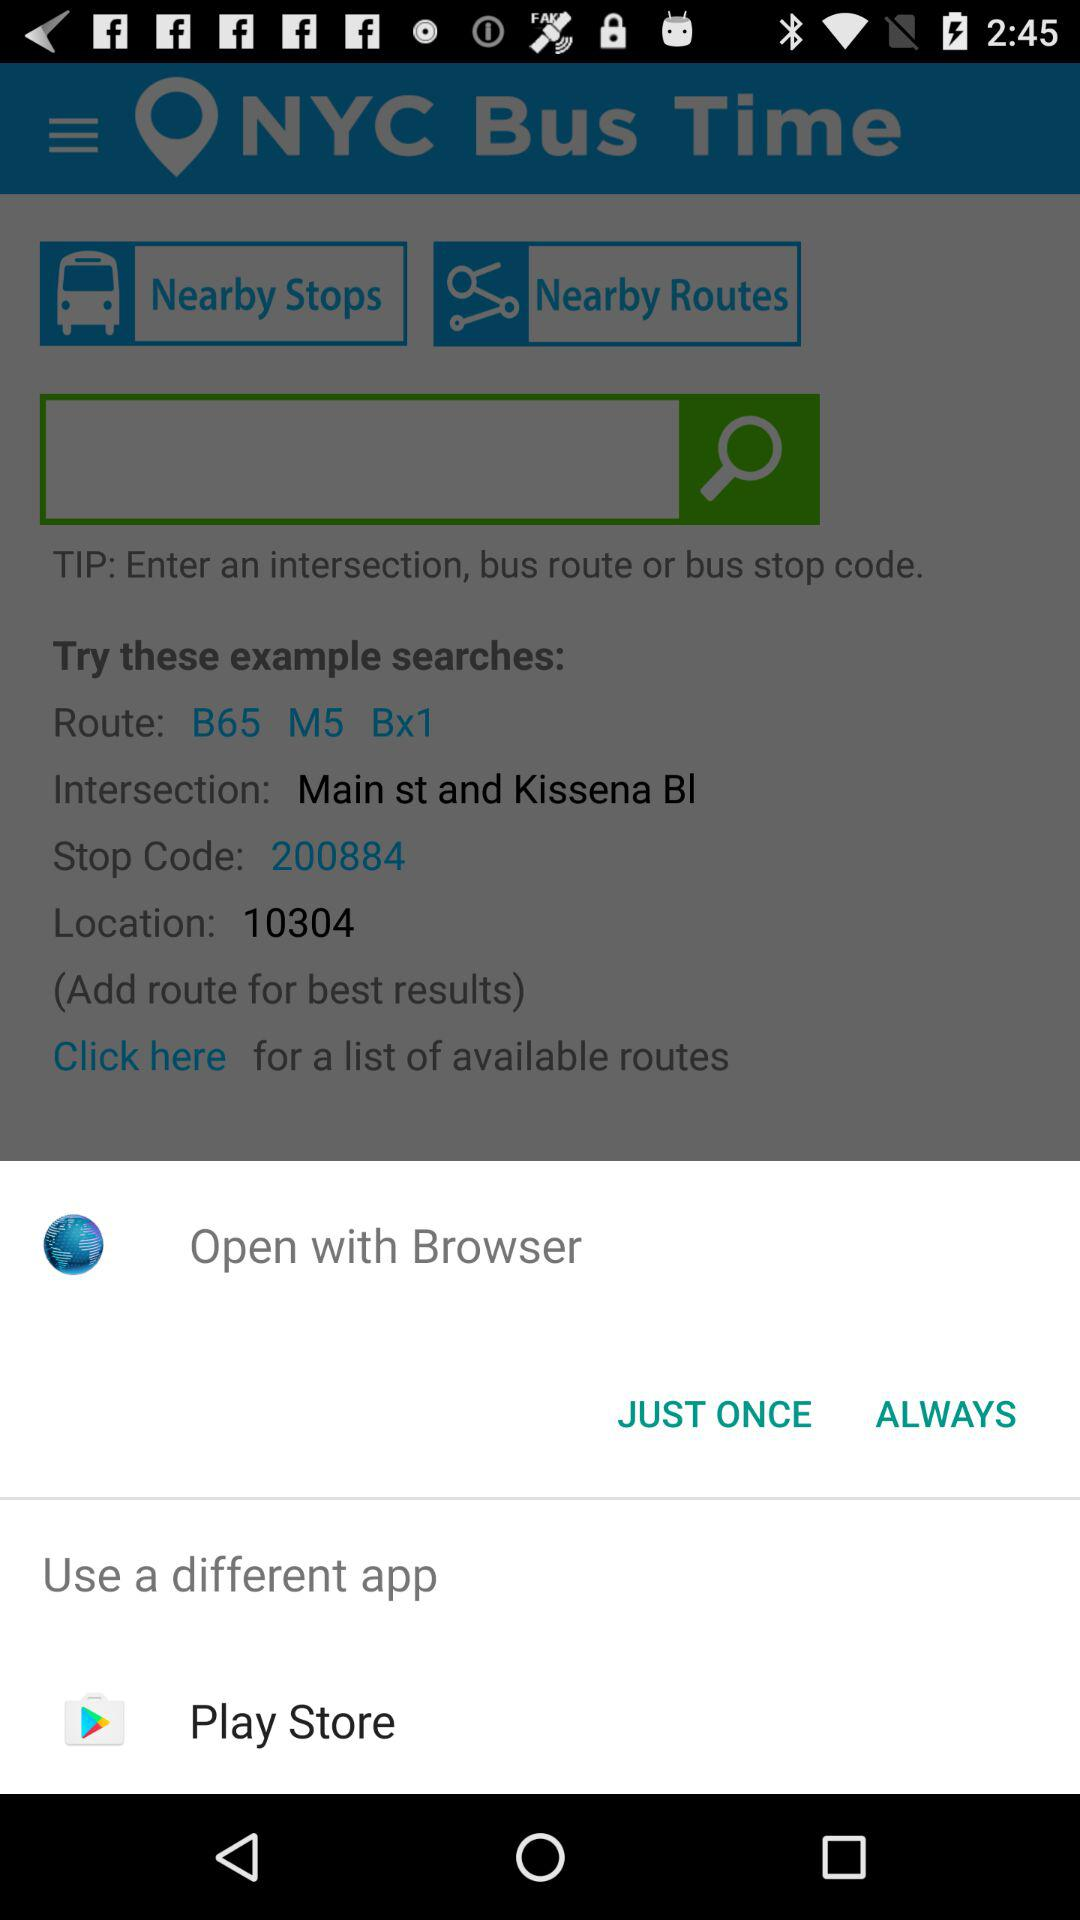What is the stop code? The stop code is 200884. 